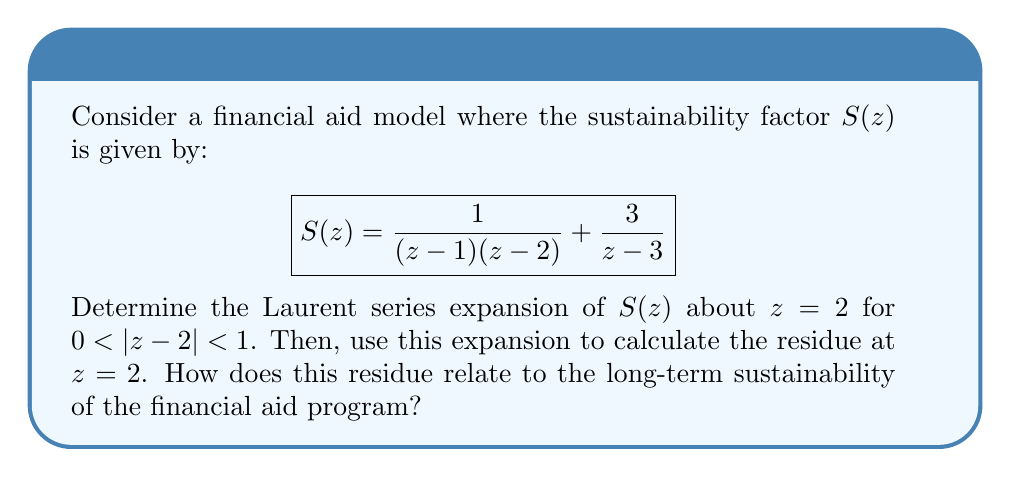What is the answer to this math problem? 1) To find the Laurent series about $z=2$, we first separate the function into two parts:

   $$S(z) = \frac{1}{(z-1)(z-2)} + \frac{3}{z-3}$$

2) For the first part, $\frac{1}{(z-1)(z-2)}$, we use partial fraction decomposition:

   $$\frac{1}{(z-1)(z-2)} = \frac{1}{z-1} - \frac{1}{z-2}$$

3) The term $\frac{1}{z-1}$ can be expanded as a geometric series about $z=2$:

   $$\frac{1}{z-1} = \frac{1}{(z-2)+1} = \frac{1}{1+(z-2)} = 1 - (z-2) + (z-2)^2 - (z-2)^3 + \cdots$$

4) The term $-\frac{1}{z-2}$ is already in the form we need for the Laurent series.

5) For $\frac{3}{z-3}$, we can expand it as a geometric series about $z=2$:

   $$\frac{3}{z-3} = \frac{3}{(z-2)+1} = 3(1 - (z-2) + (z-2)^2 - (z-2)^3 + \cdots)$$

6) Combining all terms, the Laurent series expansion about $z=2$ is:

   $$S(z) = -\frac{1}{z-2} + (1 + 3) + (-1 - 3)(z-2) + (1 + 3)(z-2)^2 + (-1 - 3)(z-2)^3 + \cdots$$

   $$= -\frac{1}{z-2} + 4 - 4(z-2) + 4(z-2)^2 - 4(z-2)^3 + \cdots$$

7) The residue at $z=2$ is the coefficient of $\frac{1}{z-2}$ in the Laurent series, which is -1.

8) In the context of financial aid sustainability, a negative residue suggests that the program may face challenges in long-term sustainability. It indicates a potential deficit or instability in the financial aid model at $z=2$, which could represent a critical point in the program's lifecycle.
Answer: Residue at $z=2$ is -1, indicating potential long-term sustainability challenges. 